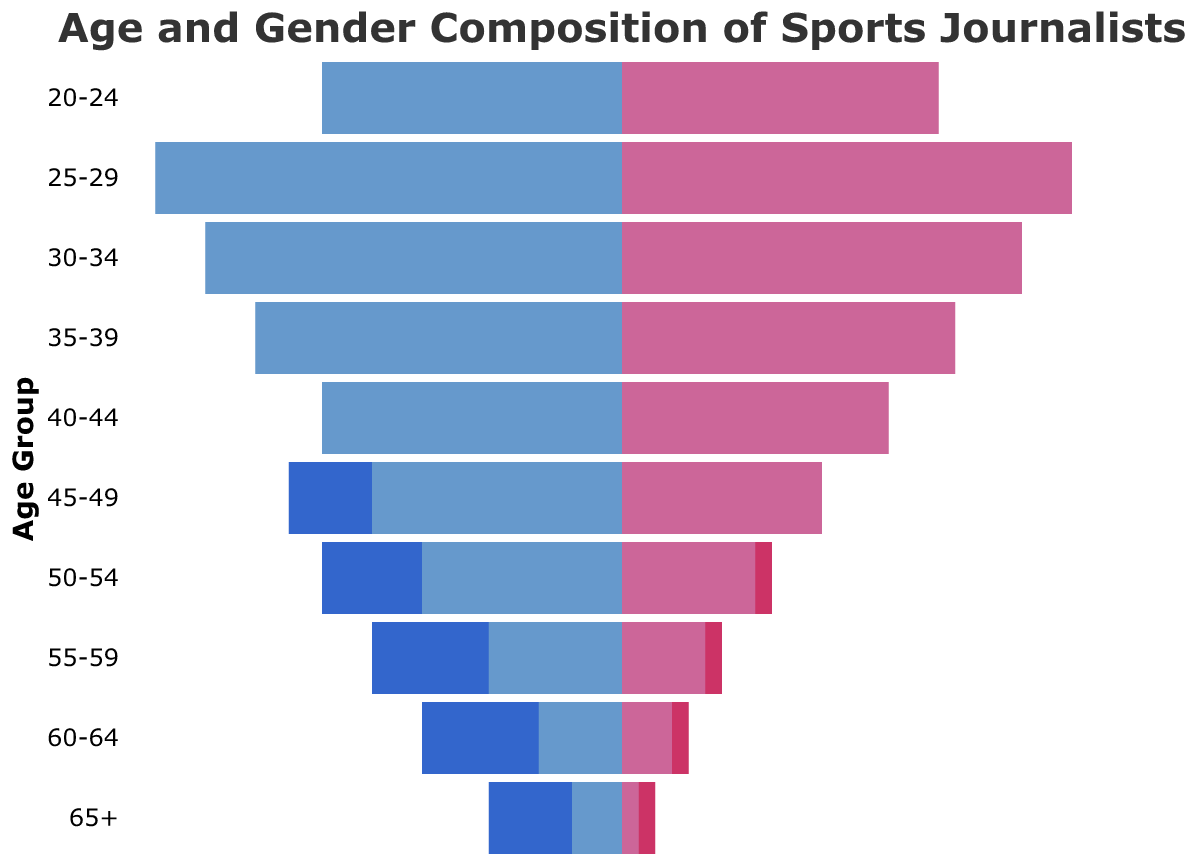What is the title of the chart? The title is positioned at the top of the chart, indicating the subject of the visualization.
Answer: Age and Gender Composition of Sports Journalists Which age group has the highest number of male digital journalists? By observing the lengths of the bars representing male digital journalists, the 25-29 age group has the longest bar.
Answer: 25-29 How many male print journalists are there in the 50-54 age group? The bar for male print journalists in the 50-54 age group has a value of 18.
Answer: 18 Compare the number of female digital journalists to male digital journalists in the 30-34 age group. The chart shows the female digital journalists with a value of 24 and male digital journalists with a value of 25 in the 30-34 age group.
Answer: Female: 24, Male: 25 What is the total number of female print journalists in the 45-49 and 55-59 age groups? Add the values for female print journalists in 45-49 (12) and 55-59 (6) age groups: 12 + 6 = 18.
Answer: 18 Which group has more journalists overall in the 40-44 age group, print or digital? Sum up the male and female journalists for both print (17 males, 14 females) and digital (18 males, 16 females) in the 40-44 age group: Print (17 + 14 = 31) and Digital (18 + 16 = 34).
Answer: Digital (34) Does the 20-24 age group have more female journalists in print or digital? Comparing the lengths of the bars for female journalists in the 20-24 age group shows that Digital (19) is higher than Print (4).
Answer: Digital (19) Compute the difference between male print and male digital journalists in the 60-64 age group. Subtract the value of male digital journalists (5) from male print journalists (12) in the 60-64 age group: 12 - 5 = 7.
Answer: 7 Which gender has more journalists in the 25-29 age group, and by how much? Add up the values for both male and female journalists in the 25-29 age group for print (Male: 7, Female: 8) and digital (Male: 28, Female: 27). Total males: 35, Total females: 35.
Answer: Equal (35) What is the ratio of male to female digital journalists in the 35-39 age group? The value for male digital journalists is 22 and female digital journalists is 20 in the 35-39 age group. Ratio = 22/20 = 1.1.
Answer: 1.1 